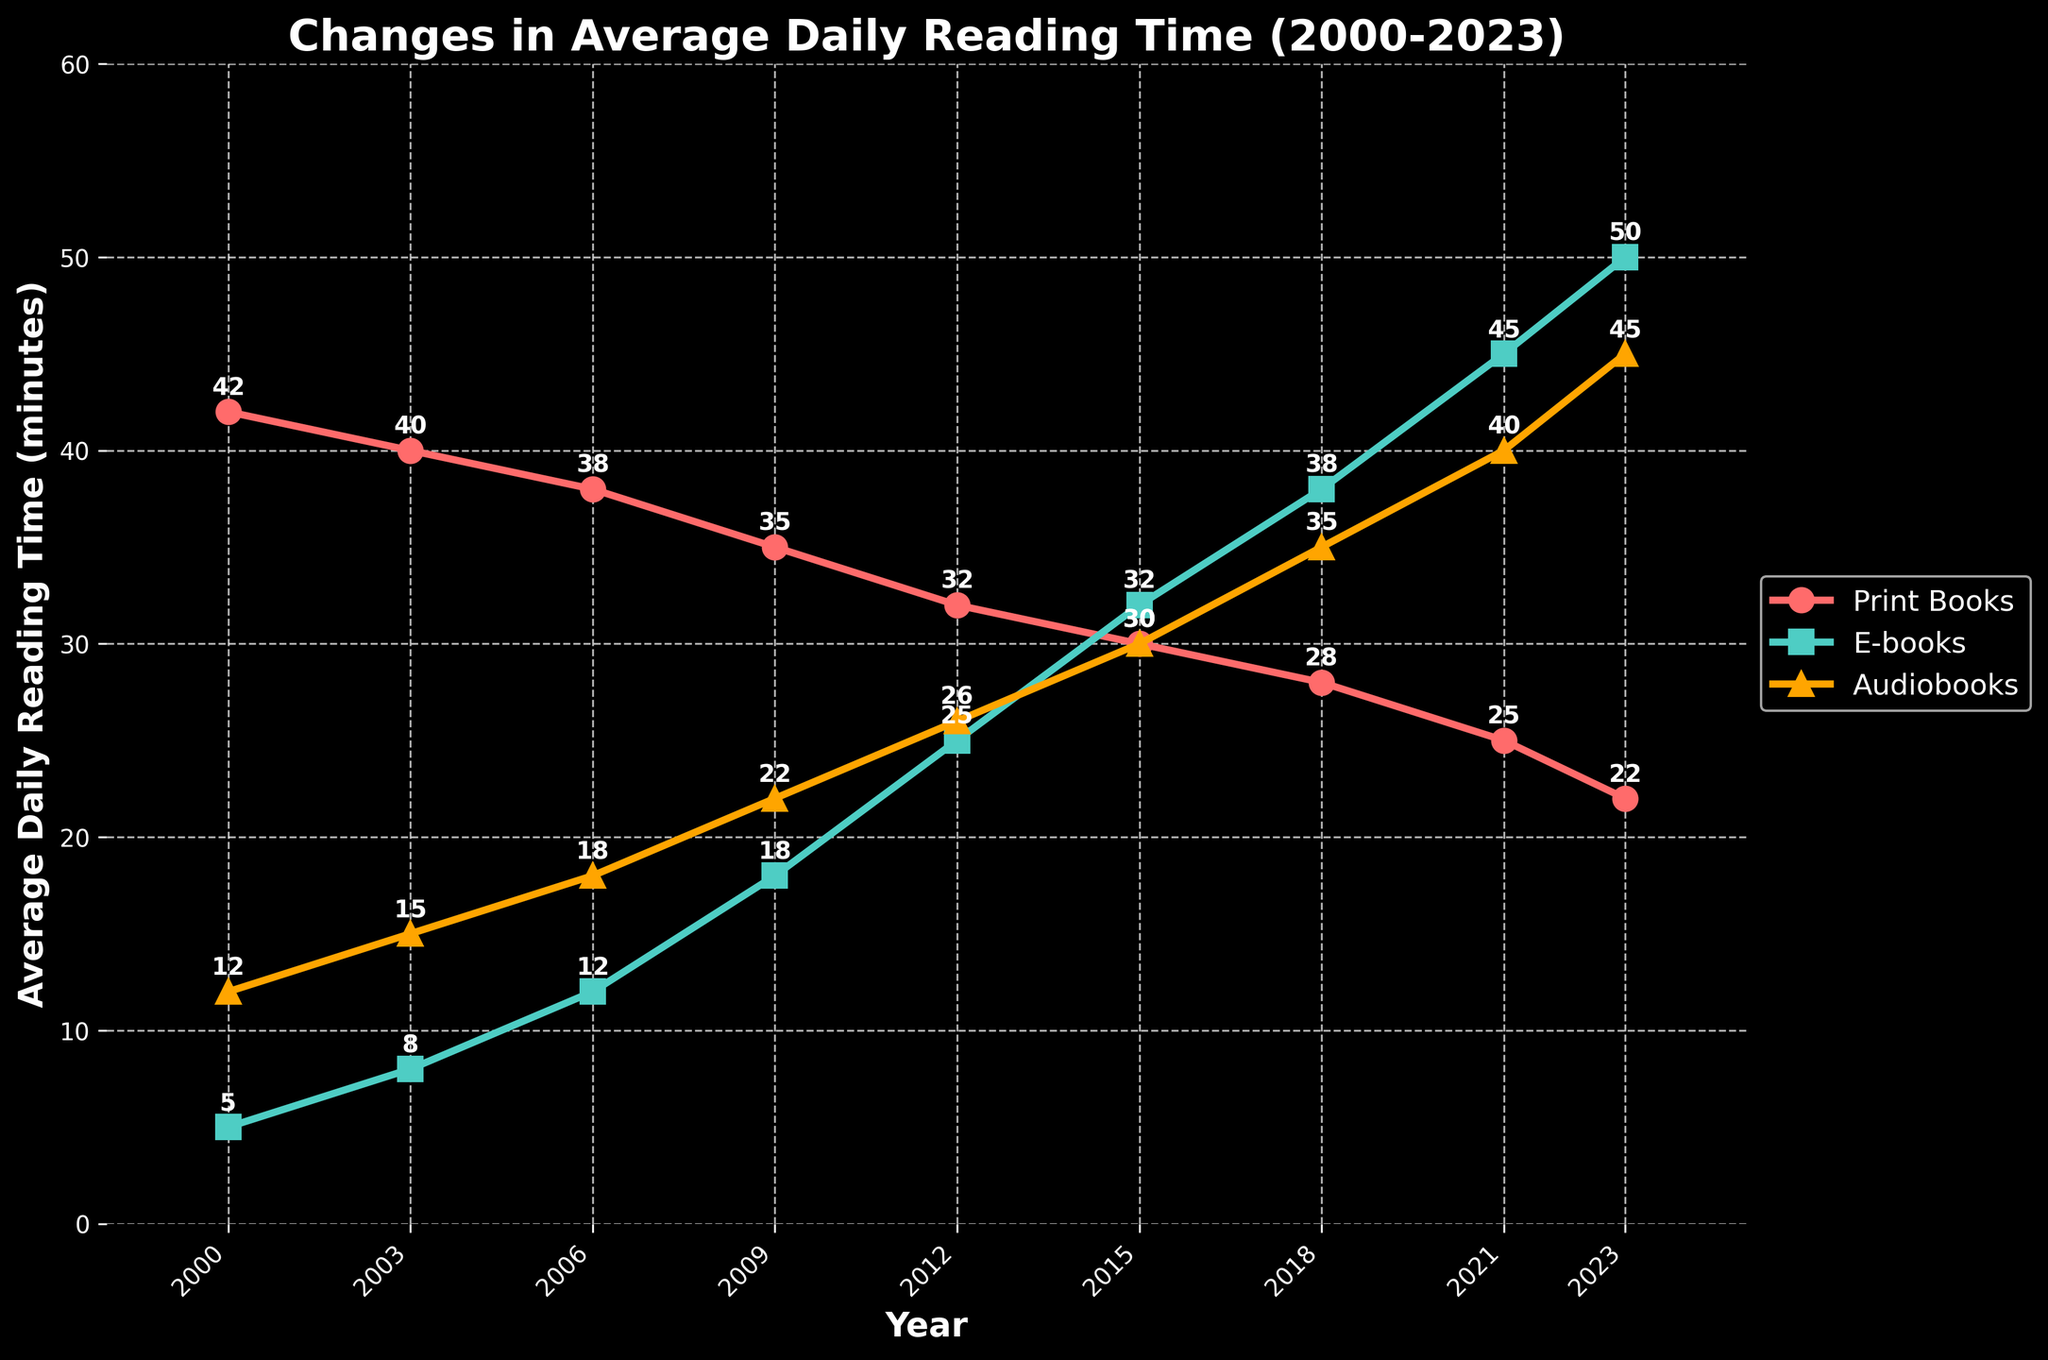How does the average daily reading time for print books change from 2000 to 2023? The average daily reading time for print books in 2000 is 42 minutes, and it gradually declines to 22 minutes in 2023.
Answer: It decreases by 20 minutes By how many minutes did the average daily reading time for e-books increase from 2000 to 2023? The average daily reading time for e-books in 2000 is 5 minutes, and it increases to 50 minutes in 2023. The difference is 50 - 5 = 45 minutes.
Answer: 45 minutes Which year saw the highest average daily reading time for audiobooks, and what was this time? The highest average daily reading time for audiobooks is 45 minutes in 2023.
Answer: 2023, 45 minutes Compare the trend of print books and e-books from 2000 to 2023. Which format shows an increasing trend and which a decreasing one? From 2000 to 2023, the average daily reading time for print books shows a decreasing trend, while that for e-books shows an increasing trend.
Answer: Print books decrease, e-books increase Which reading format had the smallest increase in average daily reading time from 2000 to 2023? For print books, the reading time decreased. Comparing the increases for e-books (45 minutes) and audiobooks (33 minutes), audiobooks had the smallest increase.
Answer: Audiobooks What is the total average daily reading for all formats combined in 2015? In 2015, print books are 30 minutes, e-books are 32 minutes, and audiobooks are 30 minutes. The total is 30 + 32 + 30 = 92 minutes.
Answer: 92 minutes Is there any year where the average daily reading time for print books is higher than the combined time for e-books and audiobooks? No, in each year, the combined time for e-books and audiobooks is higher than that for print books.
Answer: No Which year did e-books surpass print books in average daily reading time, and by how many minutes? In 2012, e-books surpassed print books. For e-books, the time is 25 minutes, and for print books, it is 32 minutes, so the difference is 32 - 25 = 7 minutes.
Answer: 2012, by 7 minutes By what percentage did the average daily reading time for audiobooks increase from 2000 to 2023? In 2000, the audiobook time was 12 minutes, and in 2023 it was 45 minutes. The increase percentage is ((45 - 12) / 12) * 100 = 275%.
Answer: 275% How does the average daily reading time for e-books in 2023 compare to that of print books and audiobooks in 2000? In 2000, print books were 42 minutes and audiobooks were 12 minutes. E-books in 2023 are 50 minutes, which is higher than both print books and audiobooks in 2000.
Answer: E-books in 2023 are higher 